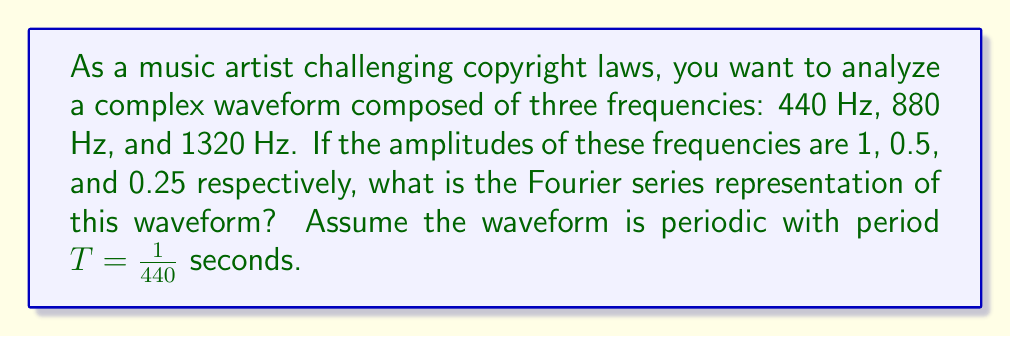Can you answer this question? 1) The Fourier series for a periodic function $f(t)$ with period $T$ is given by:

   $$f(t) = \sum_{n=-\infty}^{\infty} c_n e^{i2\pi n f_0 t}$$

   where $f_0 = \frac{1}{T}$ is the fundamental frequency.

2) In this case, $f_0 = 440$ Hz, and we have three components:
   - 440 Hz (1st harmonic): amplitude 1
   - 880 Hz (2nd harmonic): amplitude 0.5
   - 1320 Hz (3rd harmonic): amplitude 0.25

3) For real-valued signals, the complex exponential form of the Fourier series can be simplified to:

   $$f(t) = \sum_{n=1}^{\infty} A_n \cos(2\pi n f_0 t + \phi_n)$$

   where $A_n$ is the amplitude and $\phi_n$ is the phase of the nth harmonic.

4) In our case, all phases are 0, so we can write:

   $$f(t) = 1 \cos(2\pi \cdot 440t) + 0.5 \cos(2\pi \cdot 880t) + 0.25 \cos(2\pi \cdot 1320t)$$

5) This can be rewritten in terms of the fundamental frequency:

   $$f(t) = 1 \cos(2\pi f_0 t) + 0.5 \cos(4\pi f_0 t) + 0.25 \cos(6\pi f_0 t)$$

This is the Fourier series representation of the given waveform.
Answer: $f(t) = \cos(2\pi f_0 t) + 0.5 \cos(4\pi f_0 t) + 0.25 \cos(6\pi f_0 t)$, where $f_0 = 440$ Hz 